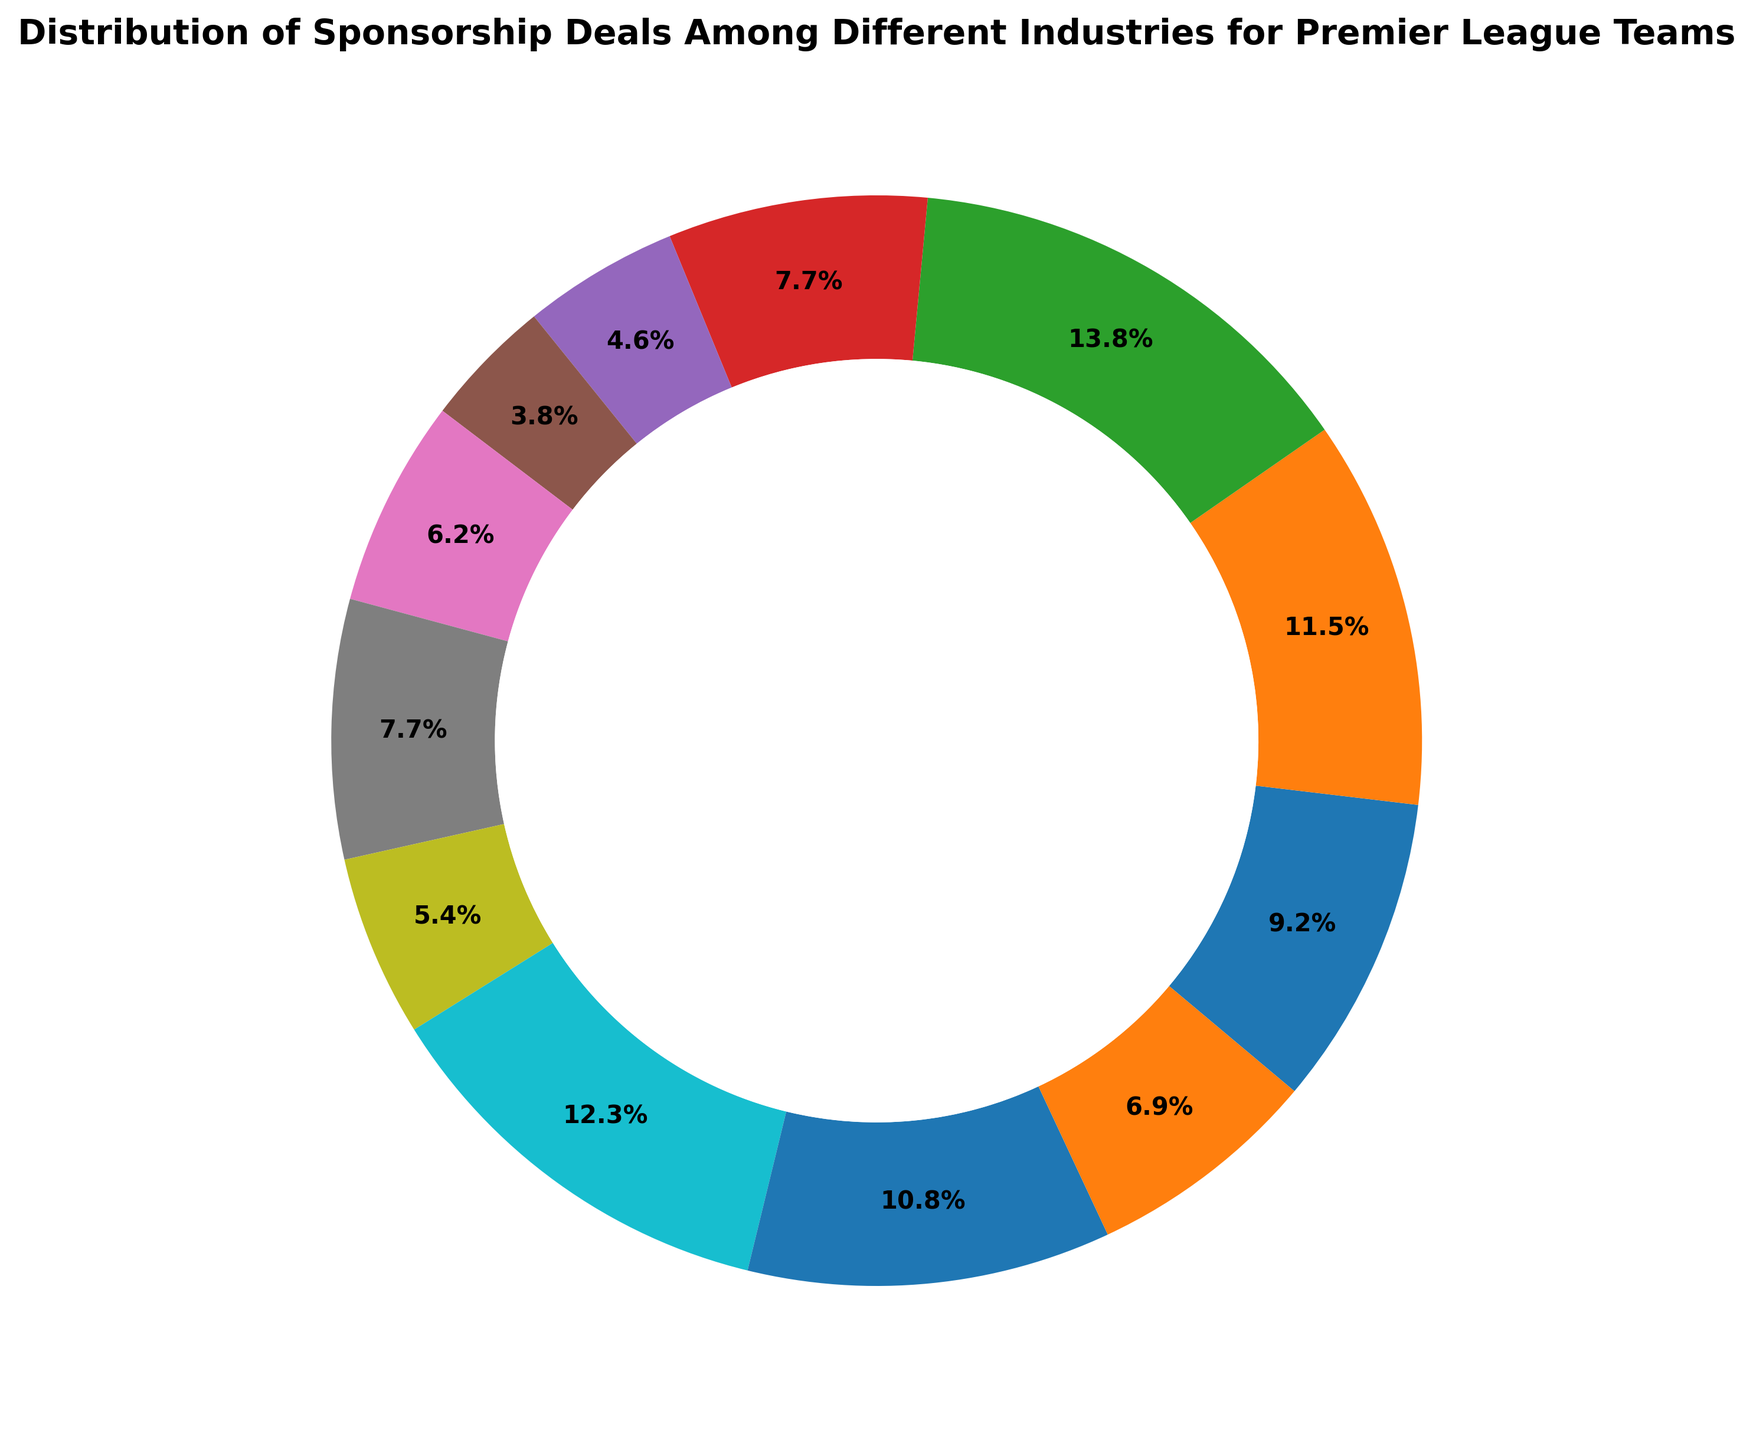What percentage of sponsorship deals comes from the Betting industry? To find the percentage, look for the sector labeled "Betting" in the chart and check the figure next to it. The chart indicates this value directly as a percentage.
Answer: 21.4% How many more sponsorship deals does the Retail industry have compared to the Broadcasting industry? Subtract the number of sponsorship deals in Broadcasting (6) from the number in Retail (16).
Answer: 10 Which industry has the fewest sponsorship deals Identify the sector with the smallest percentage or lowest count. The construction industry appears as the smallest.
Answer: Construction Are the combined sponsorship deals in the Technology and Banking industries greater than those in the Automotive and Beverages industries? Add the counts for Technology (14) and Banking (15) to get 29. Add the counts for Automotive (12) and Beverages (10) to get 22. Comparison shows 29 is greater than 22.
Answer: Yes Which industry has the most sponsorship deals after Betting? Identify the second largest segment after Betting which is Retail with 16 deals.
Answer: Retail What is the total percentage of sponsorship deals from the Automotive, Banking, and Betting industries combined? Add the percentages from Automotive, Banking, and Betting which are 14.3%, 17.9%, and 21.4% respectively. Sum them up: 14.3 + 17.9 + 21.4 = 53.6%.
Answer: 53.6% What percentage of sponsorship deals does the Healthcare industry contribute? Find the percentage indicated next to Healthcare on the chart.
Answer: 8.3% Is the percentage of sponsorship deals from Technology smaller or larger than that from Telecommunications? Compare the percentages for Technology (16.7%) and Telecommunications (10.7%). Technology has a larger percentage.
Answer: Larger Are there more sponsorship deals in the Fashion industry or in the Electronics industry? Compare the counts for Fashion (10) and Electronics (8). Fashion has more deals.
Answer: Fashion What's the difference in percentage between the highest and lowest industries in terms of sponsorship deals? Find the percentages of the highest (Betting, 21.4%) and the lowest (Construction, 6.0%). Subtract 6.0 from 21.4: 21.4 - 6.0 = 15.4%.
Answer: 15.4% 